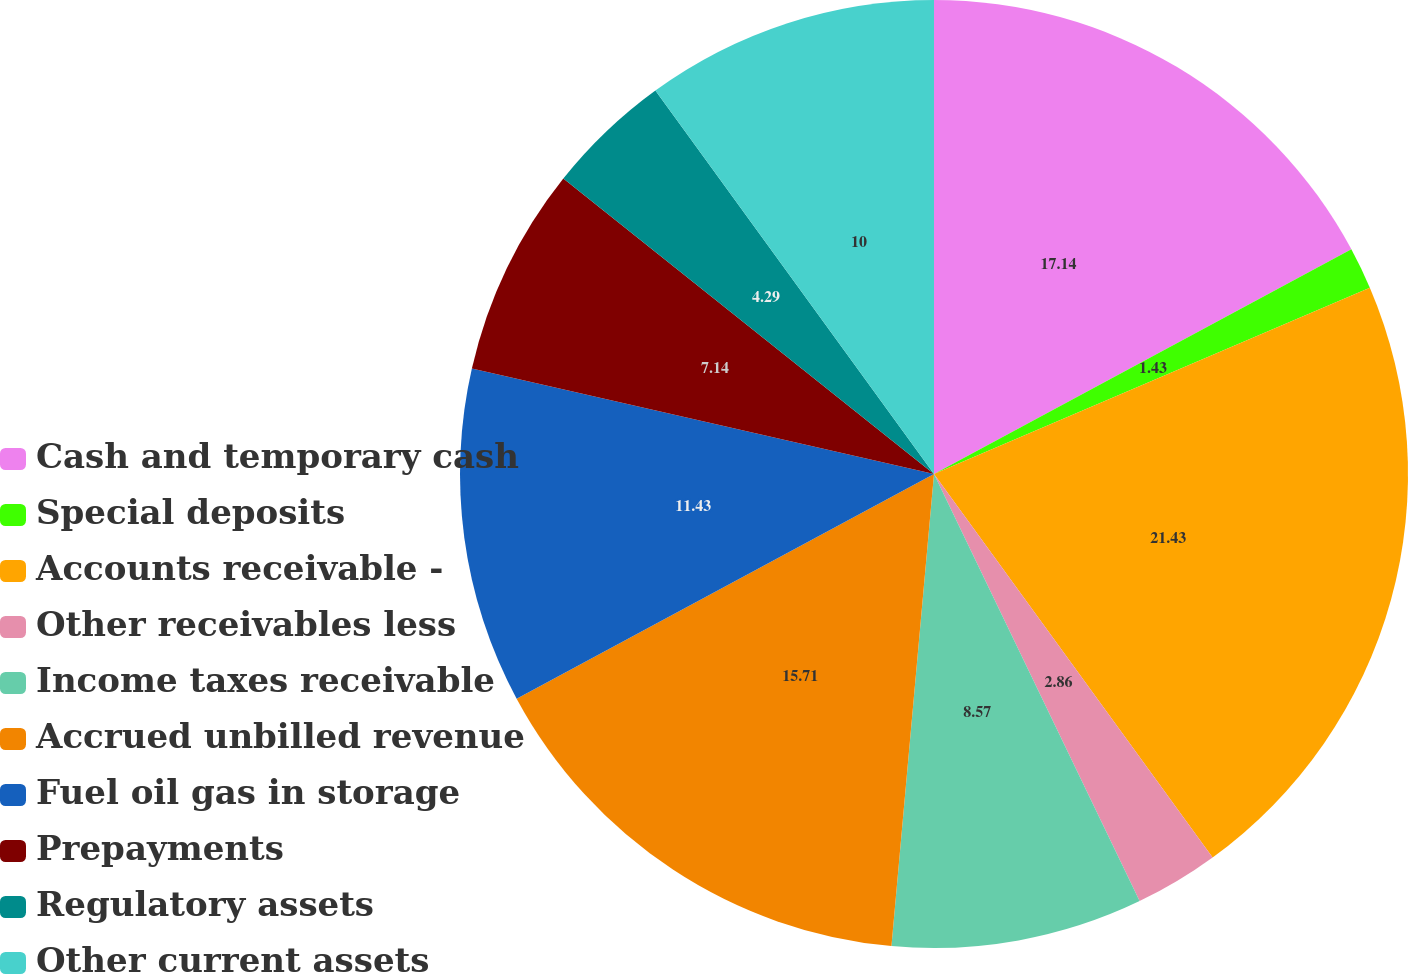<chart> <loc_0><loc_0><loc_500><loc_500><pie_chart><fcel>Cash and temporary cash<fcel>Special deposits<fcel>Accounts receivable -<fcel>Other receivables less<fcel>Income taxes receivable<fcel>Accrued unbilled revenue<fcel>Fuel oil gas in storage<fcel>Prepayments<fcel>Regulatory assets<fcel>Other current assets<nl><fcel>17.14%<fcel>1.43%<fcel>21.43%<fcel>2.86%<fcel>8.57%<fcel>15.71%<fcel>11.43%<fcel>7.14%<fcel>4.29%<fcel>10.0%<nl></chart> 